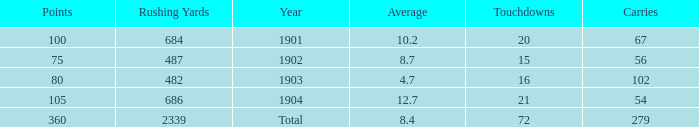What is the sum of carries associated with 80 points and fewer than 16 touchdowns? None. Could you help me parse every detail presented in this table? {'header': ['Points', 'Rushing Yards', 'Year', 'Average', 'Touchdowns', 'Carries'], 'rows': [['100', '684', '1901', '10.2', '20', '67'], ['75', '487', '1902', '8.7', '15', '56'], ['80', '482', '1903', '4.7', '16', '102'], ['105', '686', '1904', '12.7', '21', '54'], ['360', '2339', 'Total', '8.4', '72', '279']]} 